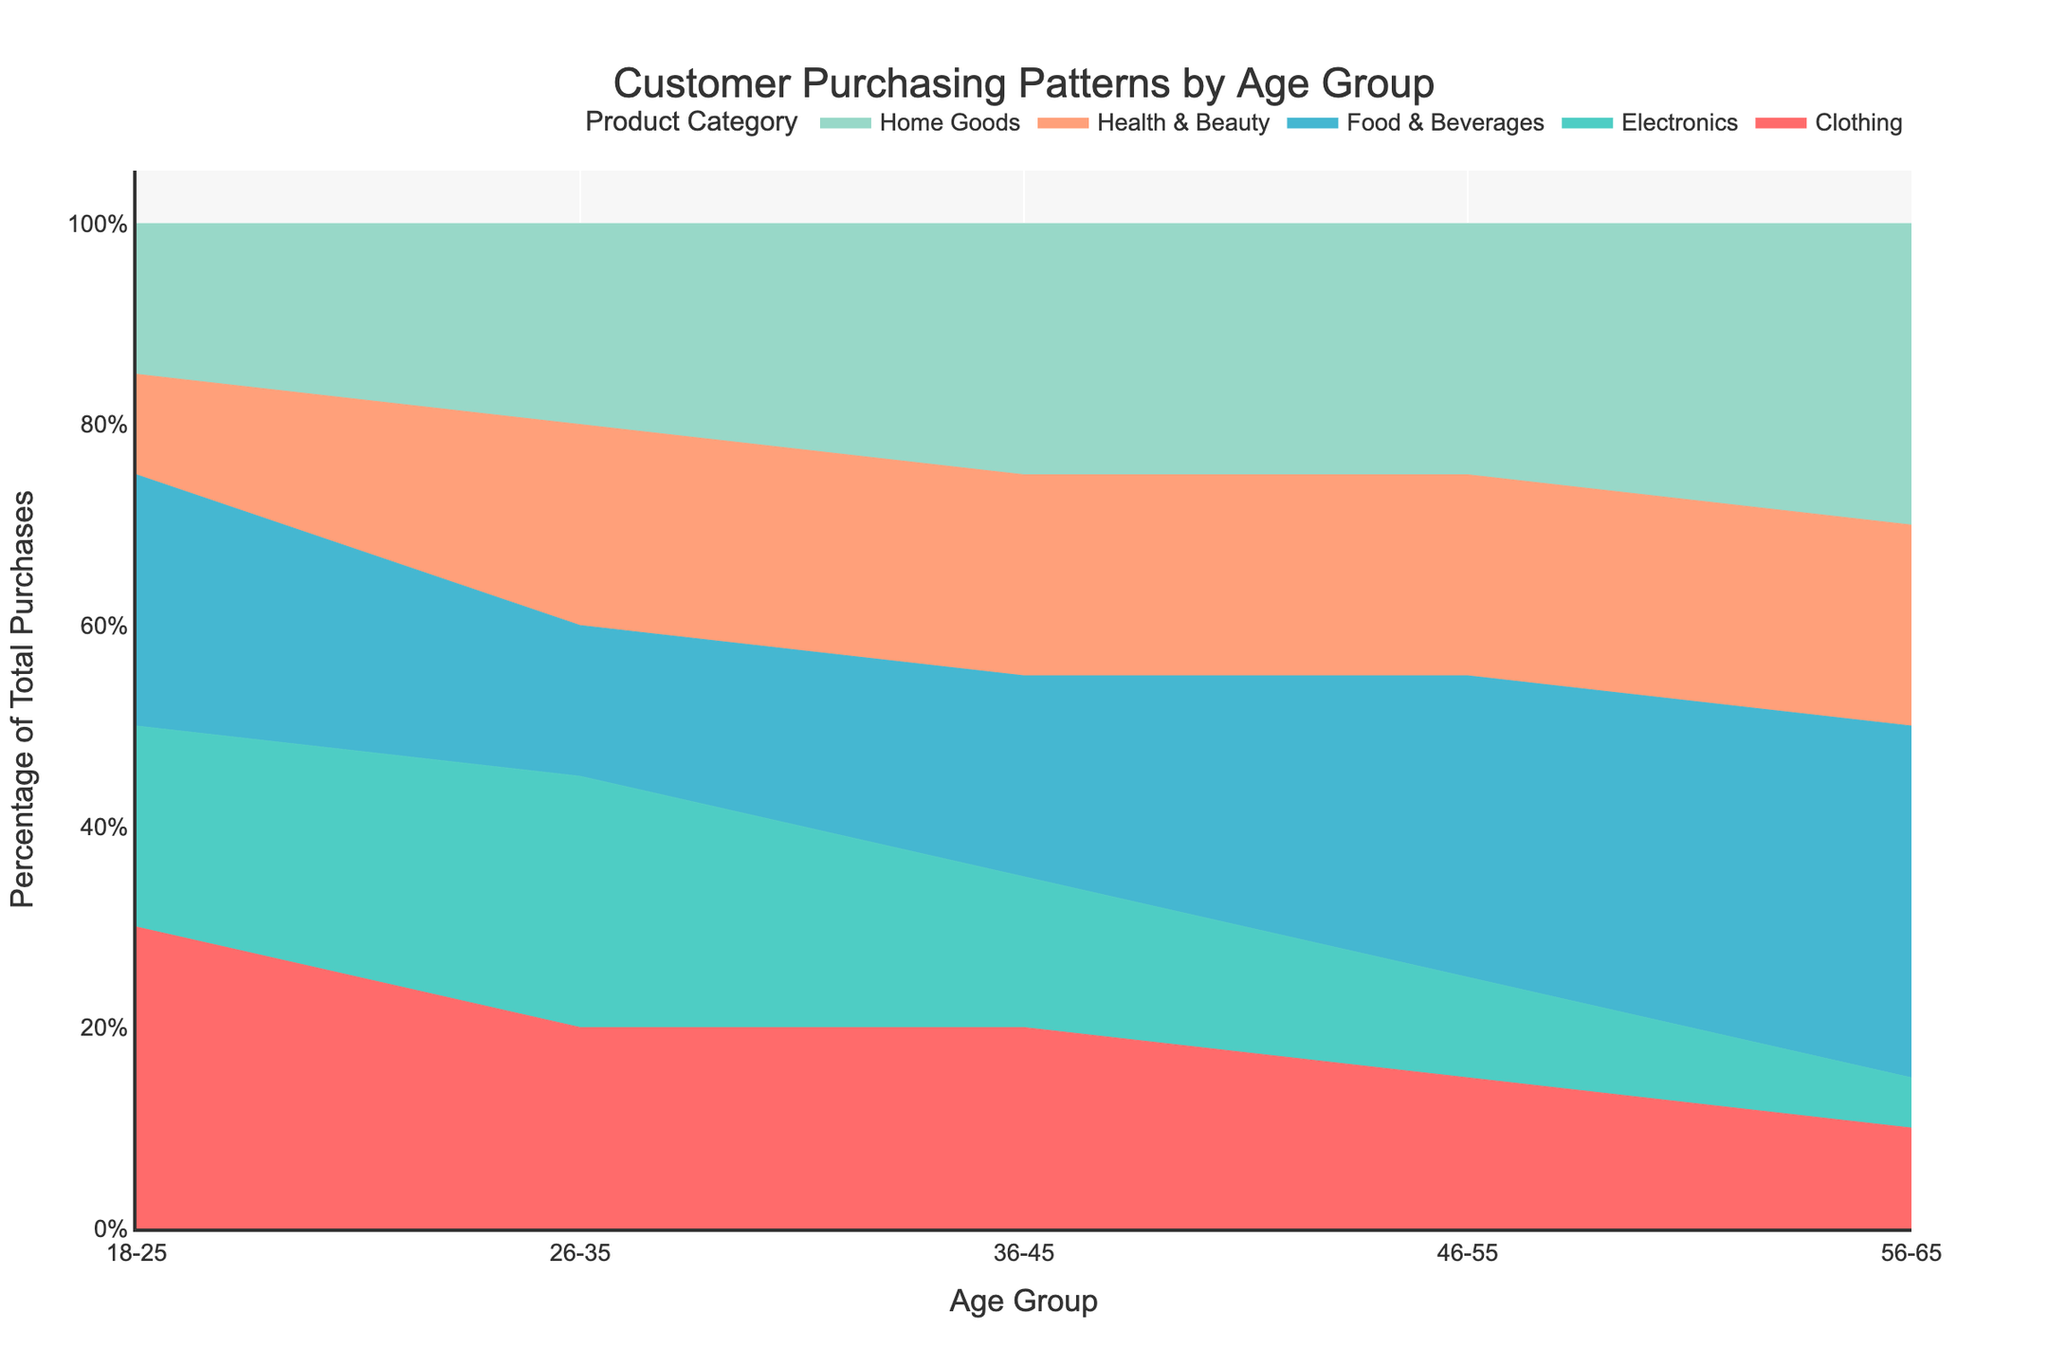What is the title of the chart? The chart title is located at the top and reads "Customer Purchasing Patterns by Age Group."
Answer: Customer Purchasing Patterns by Age Group Which age group spends the highest percentage on Food & Beverages? By looking at the area sections corresponding to Food & Beverages, the 56-65 age group has the highest percentage.
Answer: 56-65 How does the percentage of Electronics purchases compare between the 18-25 and 46-55 age groups? You observe the height of the Electronic area for both age groups; for 18-25, it's 20%, and for 46-55, it's 10%.
Answer: 18-25 has double the percentage of the 46-55 group What is the combined percentage of purchases for Home Goods and Health & Beauty for the 26-35 age group? Sum the percentages of Home Goods (20%) and Health & Beauty (20%) for the 26-35 age group.
Answer: 40% Which product category has the smallest variability in percentage across all age groups? Comparing the visual sizes of all categories across age groups, Electronics seems the most stable. Its area size doesn’t vary much from age group to age group.
Answer: Electronics How does the purchasing pattern for Clothing differ between the 18-25 and 36-45 age groups? Observe the segments for Clothing: 18-25 has 30%, and 36-45 has 20%.
Answer: 18-25 has a higher percentage in Clothing What trend do you notice for Food & Beverages from the youngest to the oldest age group? The Food & Beverages segment increases in size sequentially from 18-25 (25%) to 56-65 (35%), indicating an upward trend.
Answer: Increasing trend Which age group has the highest diversity in product category preferences? Age groups with evenly distributed percentages across categories will have higher diversity. Visual inspection shows that the 26-35 and 36-45 could be quite varied.
Answer: Likely 26-35 or 36-45 based on even spread Is there any age group where Health & Beauty consistently shows higher percentages? Health & Beauty percentages remain high at 20% for 26-35, 36-45, and 46-55 age groups.
Answer: 26-35, 36-45, and 46-55 What can you infer about the purchasing priorities of older age groups (46-55 and 56-65)? Older age groups have larger portions in Food & Beverages and Home Goods, suggesting these categories are prioritized more by these groups.
Answer: Focus on Food & Beverages and Home Goods 